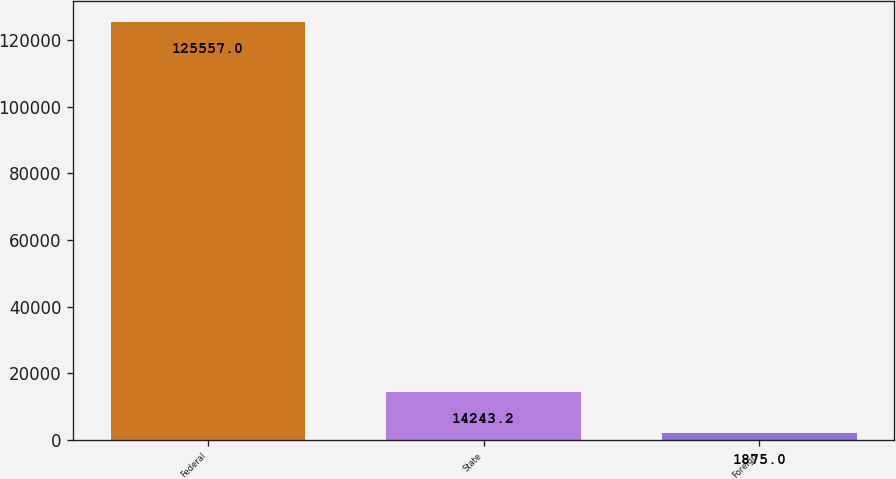Convert chart to OTSL. <chart><loc_0><loc_0><loc_500><loc_500><bar_chart><fcel>Federal<fcel>State<fcel>Foreign<nl><fcel>125557<fcel>14243.2<fcel>1875<nl></chart> 